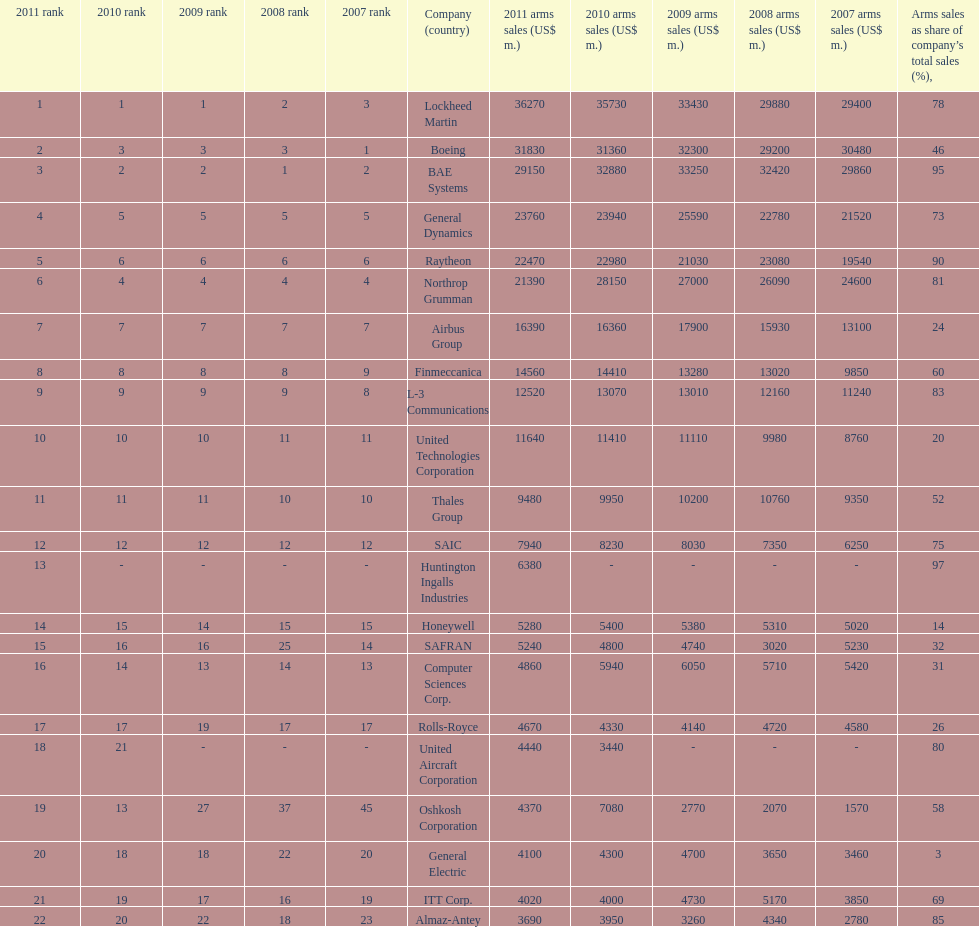What is the difference of the amount sold between boeing and general dynamics in 2007? 8960. 